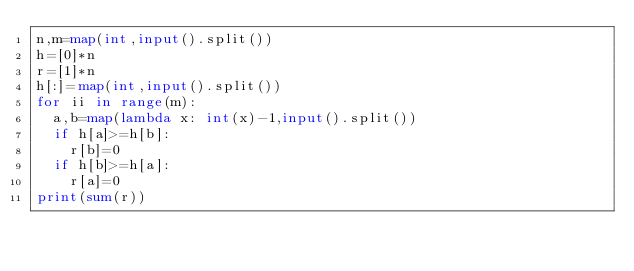<code> <loc_0><loc_0><loc_500><loc_500><_Python_>n,m=map(int,input().split())
h=[0]*n
r=[1]*n
h[:]=map(int,input().split())
for ii in range(m):
  a,b=map(lambda x: int(x)-1,input().split())
  if h[a]>=h[b]:
    r[b]=0
  if h[b]>=h[a]:
    r[a]=0
print(sum(r))
  </code> 